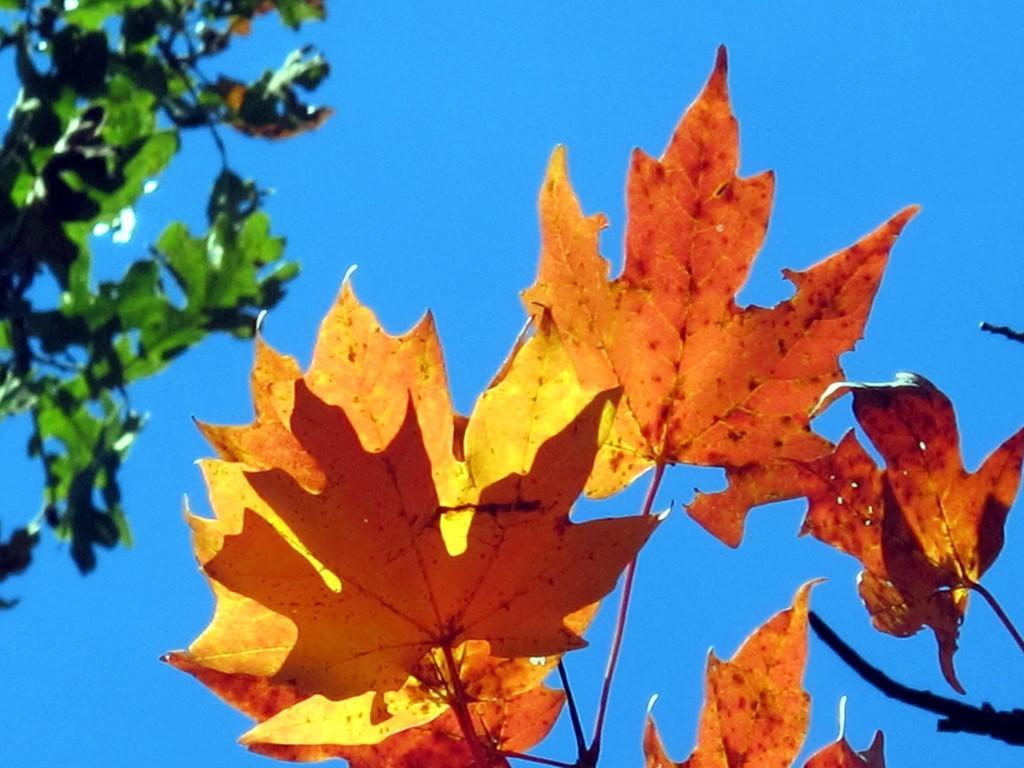Can you describe this image briefly? In the foreground of the picture there are leaves and stem. On the right there are branches of a tree. In the background it is sky. 